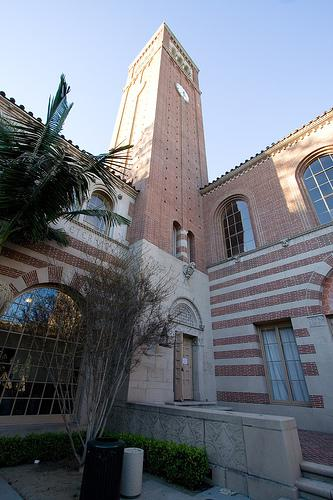Question: what is green?
Choices:
A. The shrubs.
B. The tree.
C. Grass.
D. A lime.
Answer with the letter. Answer: A Question: why are there shadows?
Choices:
A. The lights are on.
B. It is daytime.
C. Search light.
D. Sunlight.
Answer with the letter. Answer: D Question: how many stories is the building?
Choices:
A. Two.
B. Three.
C. One.
D. Four.
Answer with the letter. Answer: A 